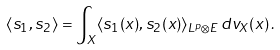<formula> <loc_0><loc_0><loc_500><loc_500>\langle s _ { 1 } , s _ { 2 } \rangle = \int _ { X } \langle s _ { 1 } ( x ) , s _ { 2 } ( x ) \rangle _ { L ^ { p } \otimes E } \, d v _ { X } ( x ) \, .</formula> 